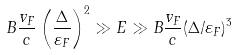Convert formula to latex. <formula><loc_0><loc_0><loc_500><loc_500>B \frac { v _ { F } } { c } \left ( \frac { \Delta } { \varepsilon _ { F } } \right ) ^ { 2 } \gg E \gg B \frac { v _ { F } } { c } ( \Delta / \varepsilon _ { F } ) ^ { 3 }</formula> 